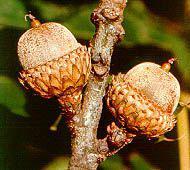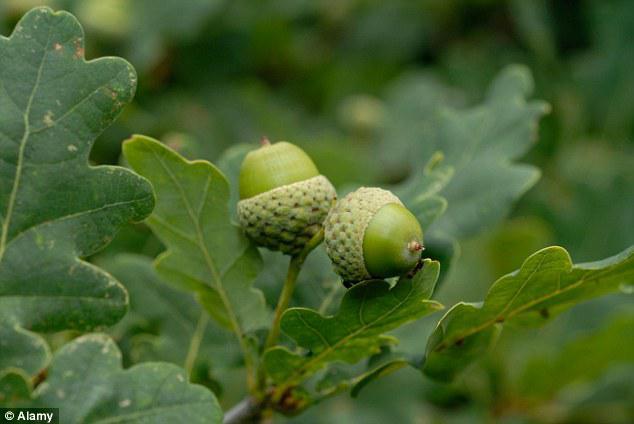The first image is the image on the left, the second image is the image on the right. Examine the images to the left and right. Is the description "There are two green acorns and green acorn tops still attach to there branch." accurate? Answer yes or no. Yes. 